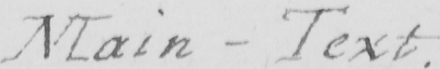What is written in this line of handwriting? Main - Text . 